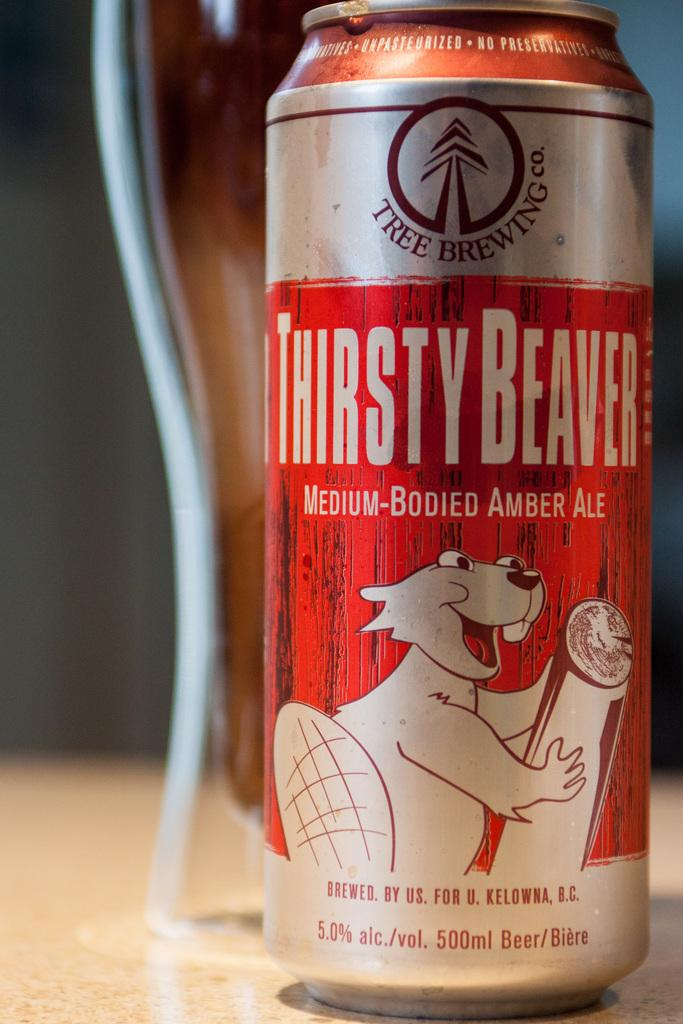Provide a one-sentence caption for the provided image. A Thirsty Beaver can of Medium-Bodied Amber Ale sits in front of a glass. 